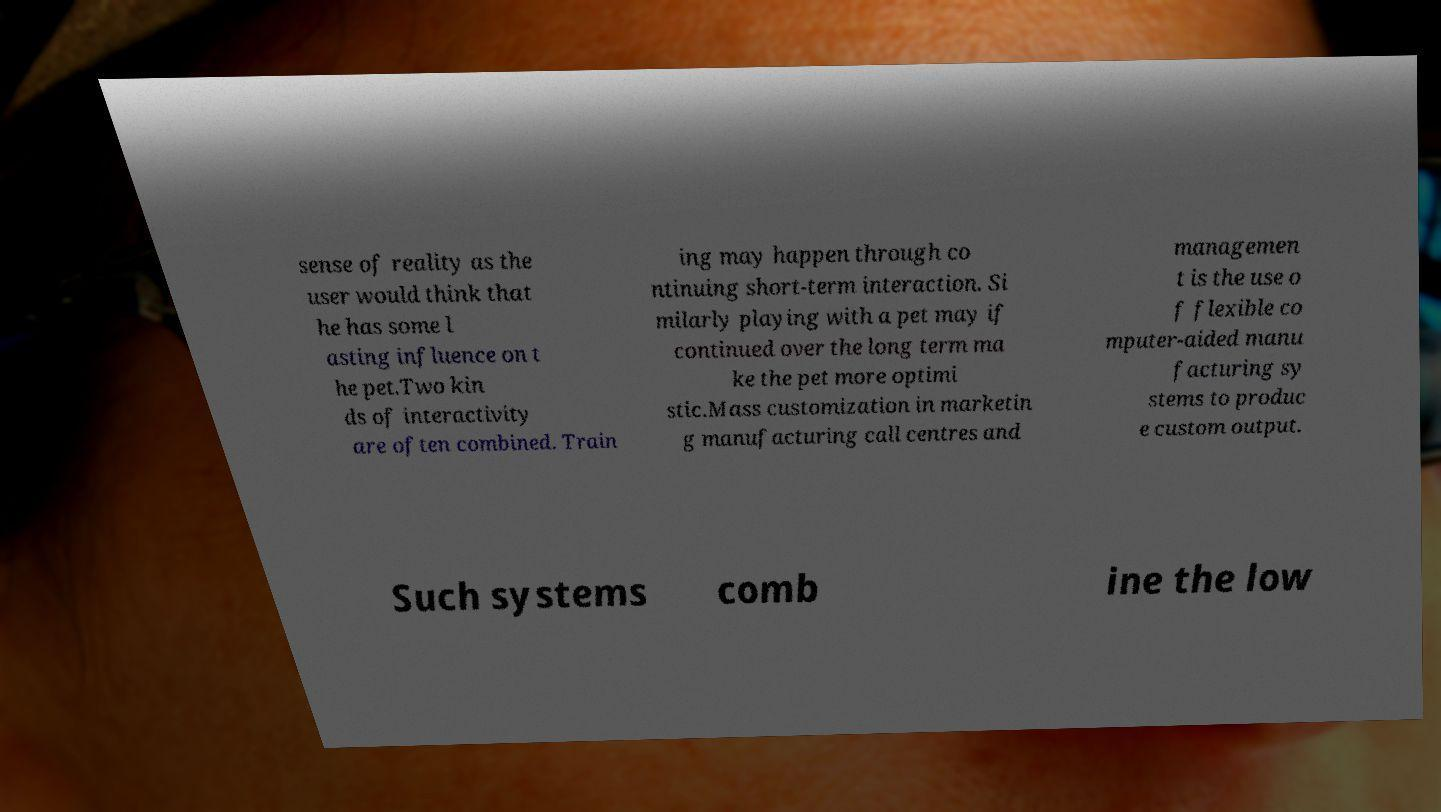I need the written content from this picture converted into text. Can you do that? sense of reality as the user would think that he has some l asting influence on t he pet.Two kin ds of interactivity are often combined. Train ing may happen through co ntinuing short-term interaction. Si milarly playing with a pet may if continued over the long term ma ke the pet more optimi stic.Mass customization in marketin g manufacturing call centres and managemen t is the use o f flexible co mputer-aided manu facturing sy stems to produc e custom output. Such systems comb ine the low 